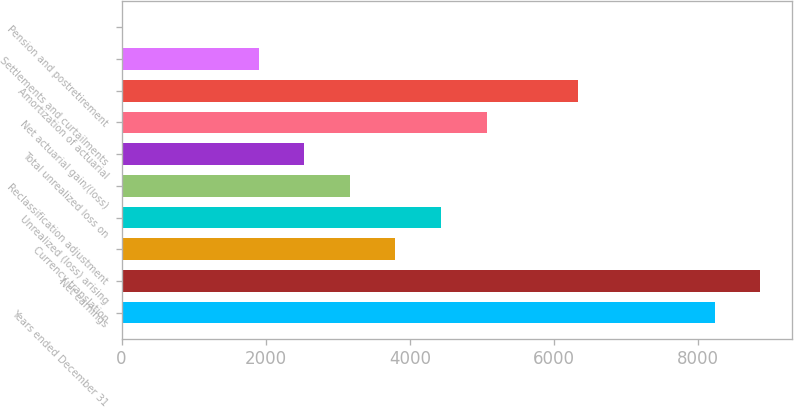<chart> <loc_0><loc_0><loc_500><loc_500><bar_chart><fcel>Years ended December 31<fcel>Net earnings<fcel>Currency translation<fcel>Unrealized (loss) arising<fcel>Reclassification adjustment<fcel>Total unrealized loss on<fcel>Net actuarial gain/(loss)<fcel>Amortization of actuarial<fcel>Settlements and curtailments<fcel>Pension and postretirement<nl><fcel>8225.5<fcel>8858<fcel>3798<fcel>4430.5<fcel>3165.5<fcel>2533<fcel>5063<fcel>6328<fcel>1900.5<fcel>3<nl></chart> 